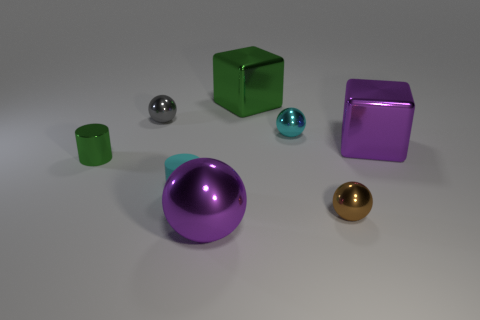Is the material of the green object that is on the right side of the tiny rubber thing the same as the cyan cylinder?
Make the answer very short. No. There is a metallic thing that is the same color as the rubber object; what is its size?
Make the answer very short. Small. How many brown metal objects have the same size as the matte object?
Your answer should be compact. 1. Are there the same number of small cylinders that are in front of the matte object and tiny metal cylinders?
Your answer should be very brief. No. How many things are left of the tiny cyan rubber cylinder and behind the cyan sphere?
Ensure brevity in your answer.  1. There is a purple ball that is the same material as the brown ball; what is its size?
Give a very brief answer. Large. How many other small things are the same shape as the brown shiny thing?
Offer a very short reply. 2. Is the number of gray shiny spheres behind the tiny cyan metallic ball greater than the number of large yellow things?
Offer a very short reply. Yes. What is the shape of the large metal thing that is in front of the gray metal thing and behind the big metallic ball?
Provide a short and direct response. Cube. Is the size of the cyan ball the same as the purple ball?
Provide a short and direct response. No. 